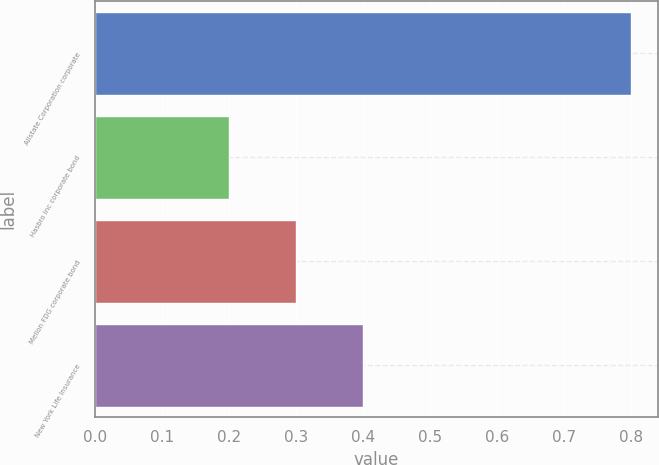Convert chart. <chart><loc_0><loc_0><loc_500><loc_500><bar_chart><fcel>Allstate Corporation corporate<fcel>Hasbro Inc corporate bond<fcel>Mellon FDG corporate bond<fcel>New York Life Insurance<nl><fcel>0.8<fcel>0.2<fcel>0.3<fcel>0.4<nl></chart> 